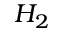Convert formula to latex. <formula><loc_0><loc_0><loc_500><loc_500>H _ { 2 }</formula> 